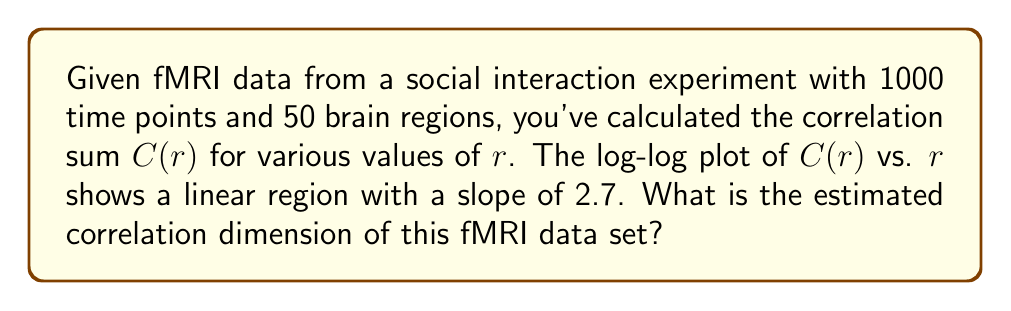Help me with this question. To estimate the correlation dimension from fMRI data, we follow these steps:

1. The correlation sum $C(r)$ is calculated for various distances $r$ in the phase space reconstructed from the fMRI time series.

2. A log-log plot of $C(r)$ vs. $r$ is created.

3. The correlation dimension $D_2$ is estimated from the slope of the linear region in this log-log plot.

4. The relationship between $C(r)$ and $r$ in the scaling region is given by:

   $$C(r) \propto r^{D_2}$$

5. Taking the logarithm of both sides:

   $$\log(C(r)) \propto D_2 \log(r)$$

6. This shows that the slope of the log-log plot in the linear region directly corresponds to the correlation dimension $D_2$.

7. In this case, the given slope is 2.7.

Therefore, the estimated correlation dimension $D_2$ of the fMRI data set is 2.7.

This non-integer dimension suggests that the brain activity during social interaction exhibits fractal-like properties, reflecting the complex, self-similar nature of neural dynamics across different scales.
Answer: $D_2 = 2.7$ 